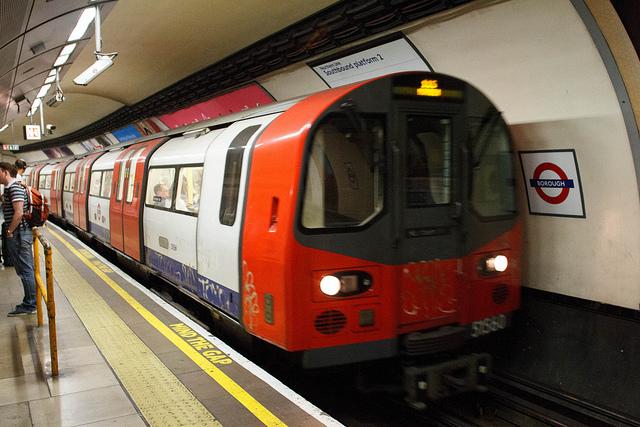Is the train facing towards the camera?
Quick response, please. Yes. What are on?
Answer briefly. Train. Are there lights on the train?
Give a very brief answer. Yes. 